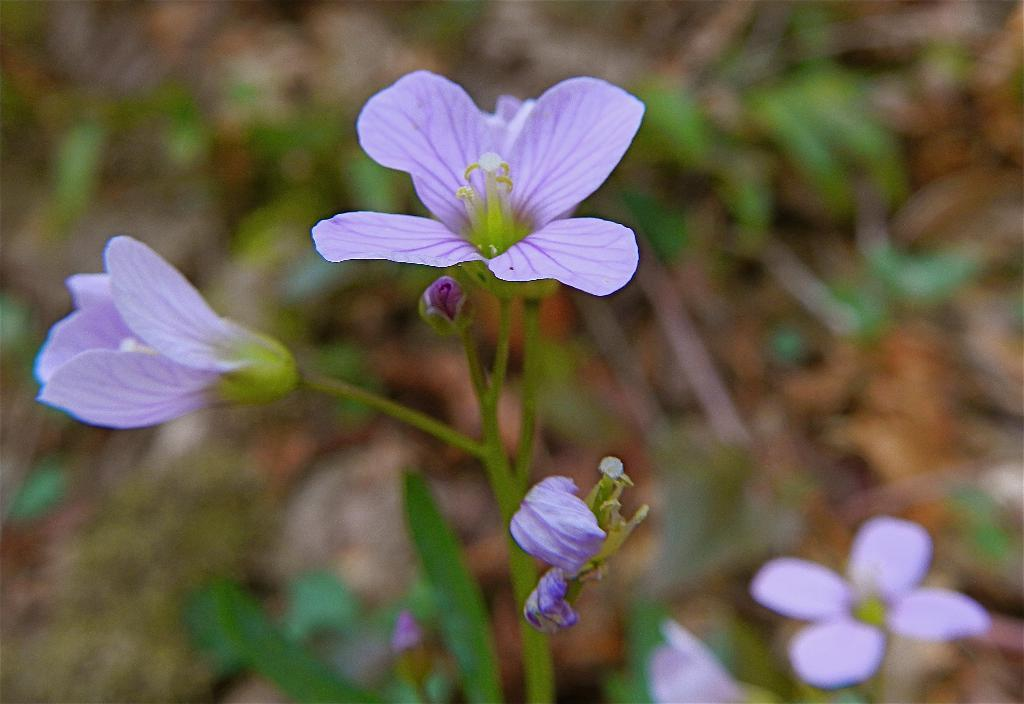What type of living organisms are in the image? There are plants in the image. What specific feature of the plants can be observed? The plants have flowers. What is the color of the flowers on the plants? The flowers are purple in color. What type of insect can be seen crawling on the knife in the image? There is no knife or insect present in the image; it features plants with purple flowers. 